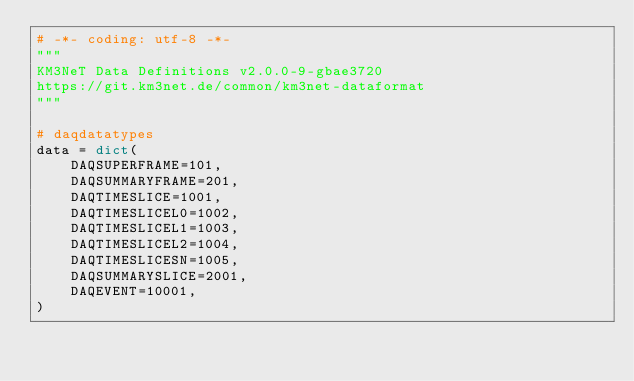<code> <loc_0><loc_0><loc_500><loc_500><_Python_># -*- coding: utf-8 -*-
"""
KM3NeT Data Definitions v2.0.0-9-gbae3720
https://git.km3net.de/common/km3net-dataformat
"""

# daqdatatypes
data = dict(
    DAQSUPERFRAME=101,
    DAQSUMMARYFRAME=201,
    DAQTIMESLICE=1001,
    DAQTIMESLICEL0=1002,
    DAQTIMESLICEL1=1003,
    DAQTIMESLICEL2=1004,
    DAQTIMESLICESN=1005,
    DAQSUMMARYSLICE=2001,
    DAQEVENT=10001,
)
</code> 